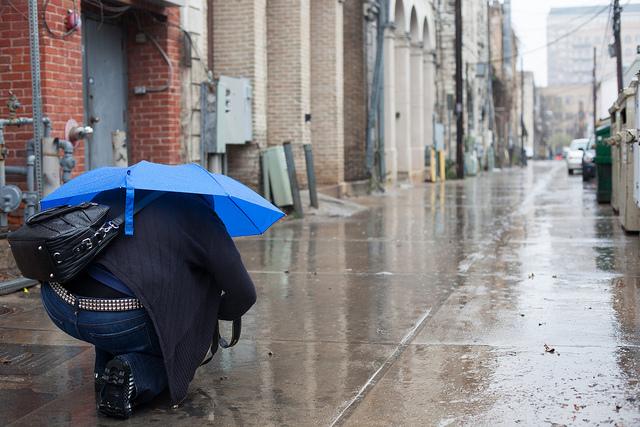Is the person under the umbrella looking for something?
Answer briefly. Yes. What kind of weather is shown here?
Concise answer only. Rainy. Which color of umbrella are many?
Write a very short answer. Blue. What color is the umbrella?
Short answer required. Blue. 